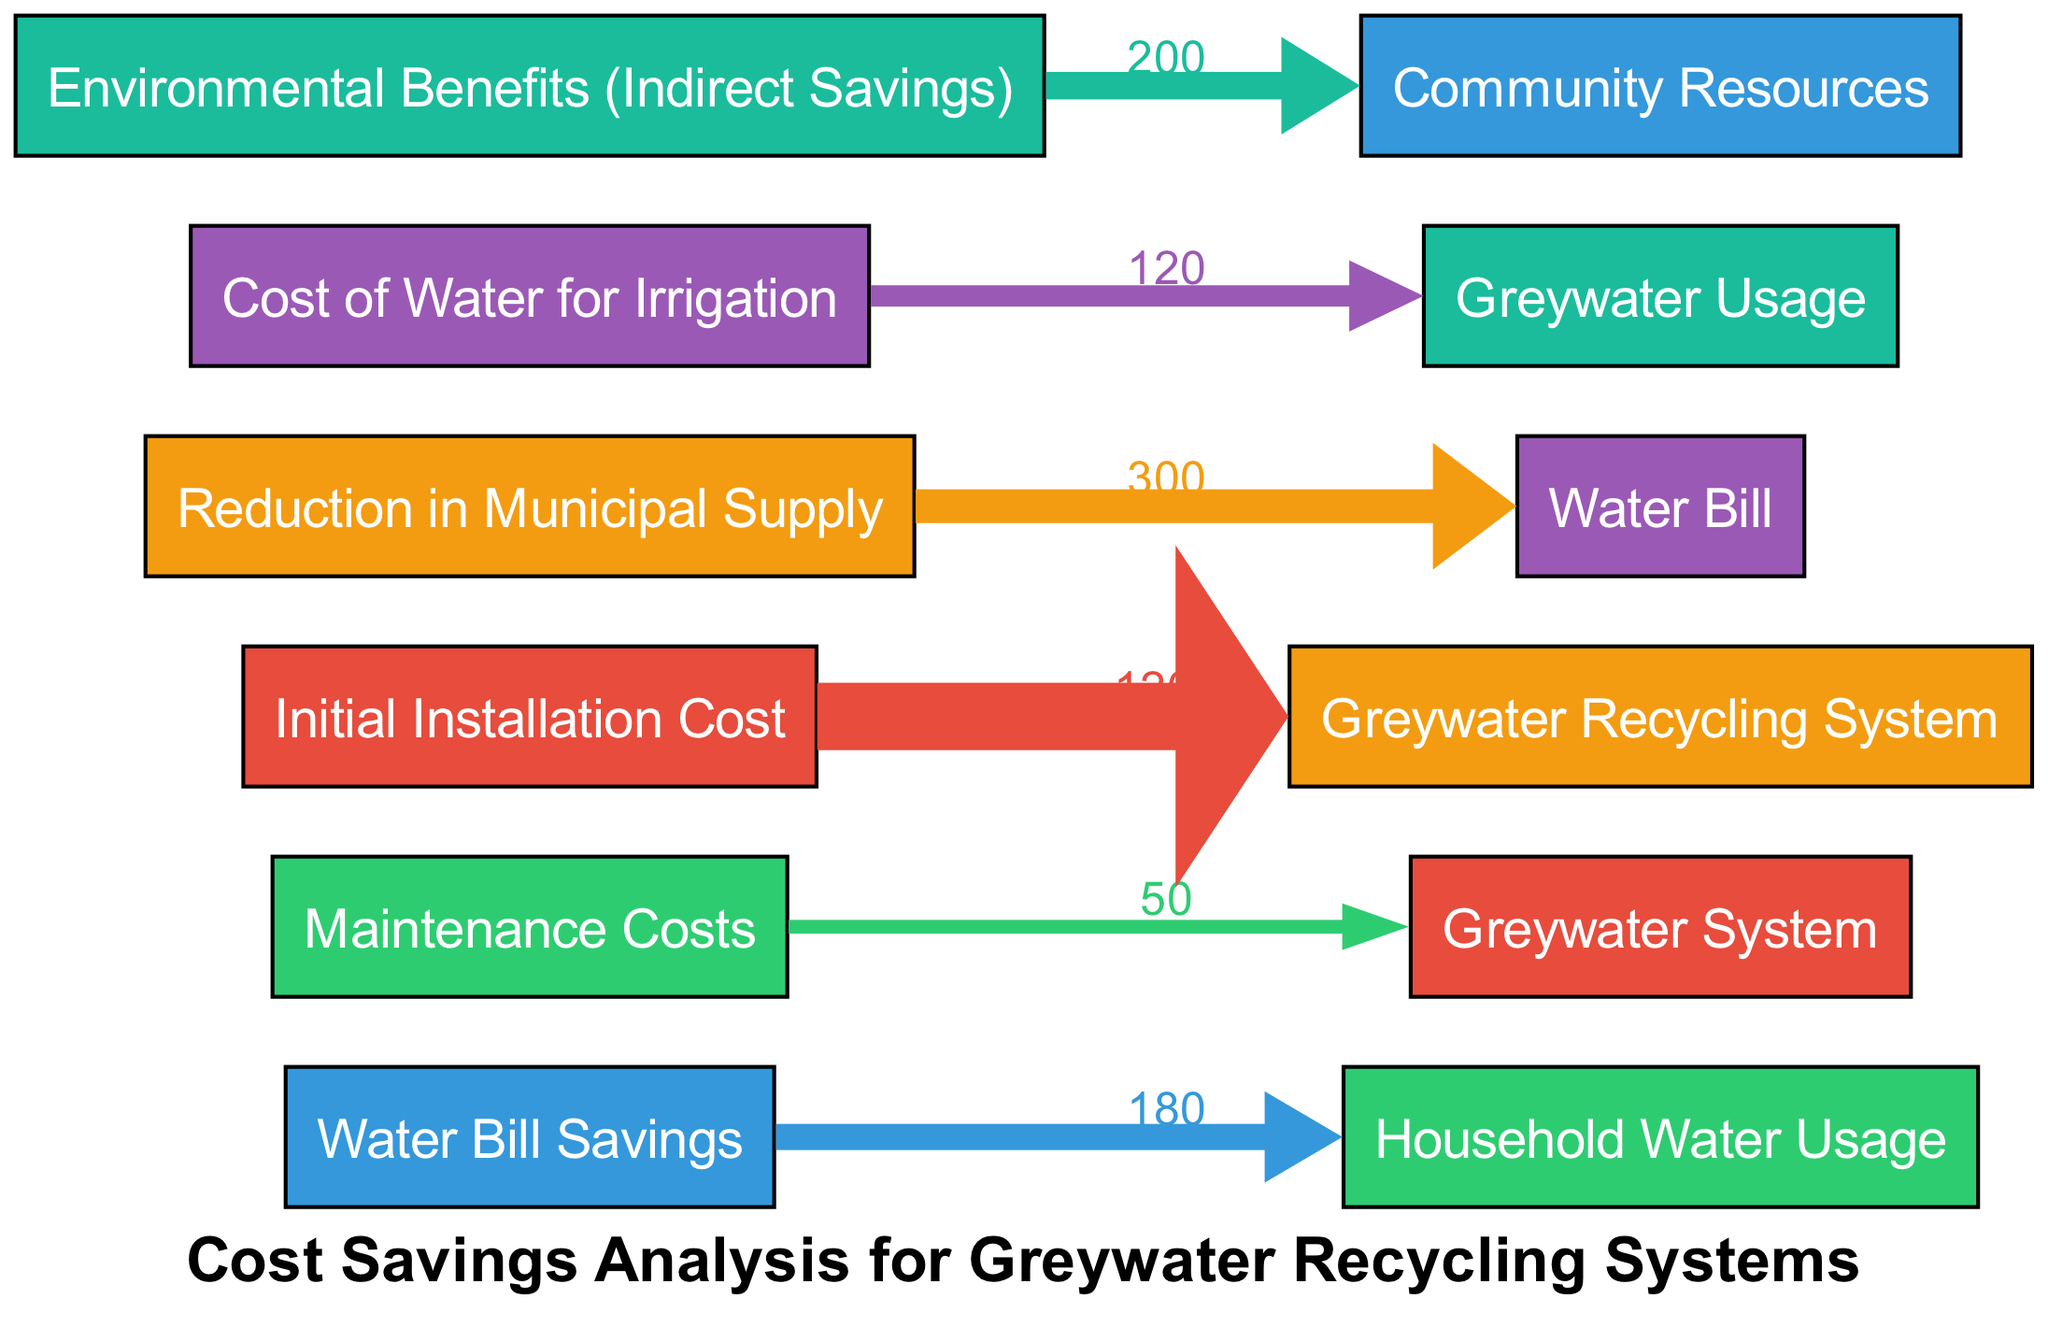What is the total value for Water Bill Savings? The Water Bill Savings node has a value of 180 associated with it, which represents the total savings from reduced water bills due to greywater recycling.
Answer: 180 How much is the Initial Installation Cost for a Greywater Recycling System? The Initial Installation Cost node indicates a value of 1200. This is the total amount typically required to install a greywater recycling system.
Answer: 1200 What represents the reduction in Municipal Supply and its value? The Reduction in Municipal Supply is connected to the Water Bill node, which has a value of 300. This value shows how much less water is supplied from municipal sources due to recycling.
Answer: 300 How does the Cost of Water for Irrigation relate to Greywater Usage? The Cost of Water for Irrigation has a value of 120 and leads to the Greywater Usage node, showing that recycling contributes to reduced costs for irrigation.
Answer: 120 What is the total value for Environmental Benefits? The Environmental Benefits node features a value of 200, which signifies the indirect savings to community resources due to implementing greywater systems.
Answer: 200 What are the maintenance costs for the Greywater System? The maintenance costs are indicated by a value of 50 in the Maintenance Costs node, showing the approximate annual upkeep expenses for the greywater system.
Answer: 50 Which relationship has the highest value in the flow? The highest individual flow value is the reduction in Municipal Supply, with a value of 300 flowing towards the Water Bill node. This reflects significant savings in municipal water use.
Answer: 300 How many total nodes are present in the diagram? After counting the identifiable nodes visible in the diagram, there are six distinct nodes: Water Bill Savings, Maintenance Costs, Initial Installation Cost, Reduction in Municipal Supply, Cost of Water for Irrigation, and Environmental Benefits.
Answer: 6 What benefits do the Environmental Benefits flow into? The Environmental Benefits flow into the Community Resources node, which signifies that these indirect benefits ultimately support larger community sustainability efforts.
Answer: Community Resources 